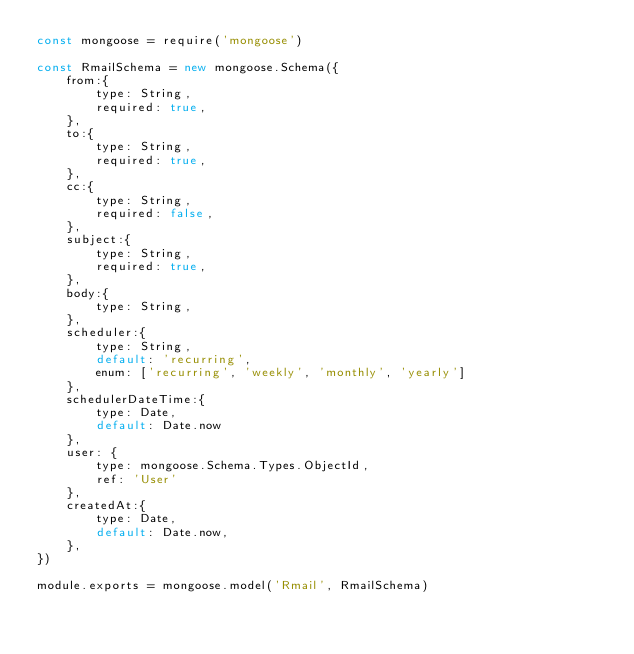Convert code to text. <code><loc_0><loc_0><loc_500><loc_500><_JavaScript_>const mongoose = require('mongoose')

const RmailSchema = new mongoose.Schema({
    from:{
        type: String,
        required: true,
    },
    to:{
        type: String,
        required: true,
    },
    cc:{
        type: String,
        required: false,
    },
    subject:{
        type: String,
        required: true,
    },
    body:{
        type: String,
    },
    scheduler:{
        type: String,
        default: 'recurring',
        enum: ['recurring', 'weekly', 'monthly', 'yearly']
    },
    schedulerDateTime:{
        type: Date,
        default: Date.now
    },
    user: {
        type: mongoose.Schema.Types.ObjectId,
        ref: 'User'
    },
    createdAt:{
        type: Date,
        default: Date.now,
    },
})

module.exports = mongoose.model('Rmail', RmailSchema)</code> 